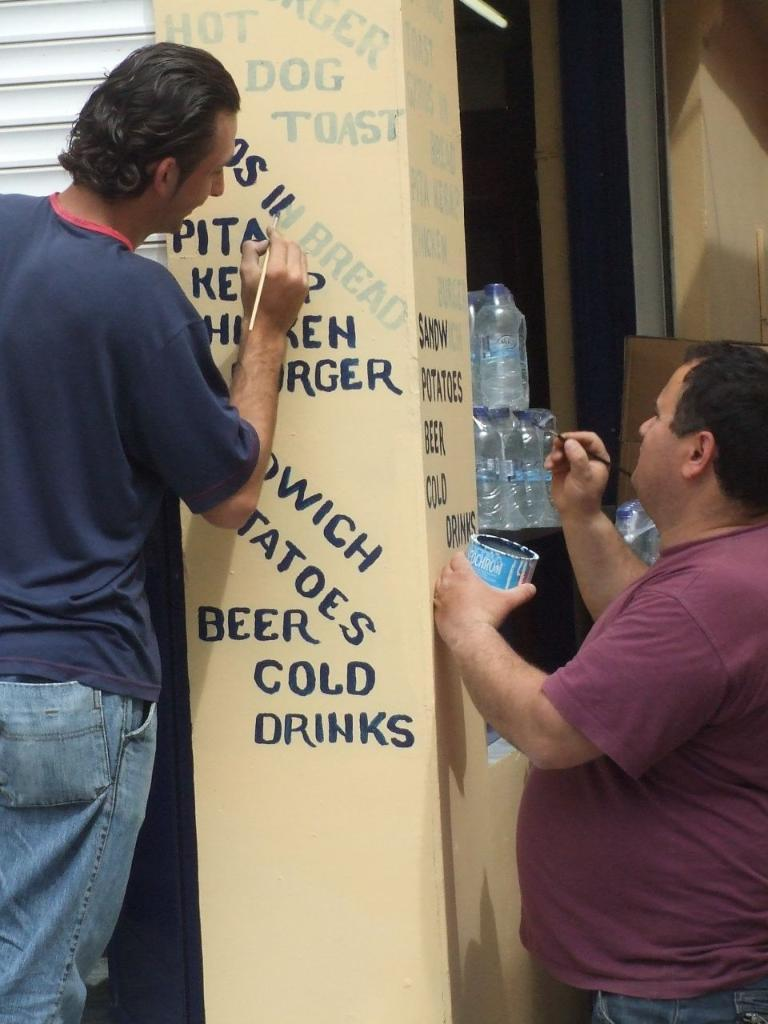How many people are in the image? There are two persons in the image. What are the persons doing in the image? The persons are painting on a wall. What might the persons be using to stay hydrated while painting? Water bottles are visible in the image, which might be used for hydration. What type of gate can be seen in the image? There is no gate present in the image; it features two persons painting on a wall. Can you describe the acoustics of the room in the image? The provided facts do not give any information about the acoustics of the room in the image. 